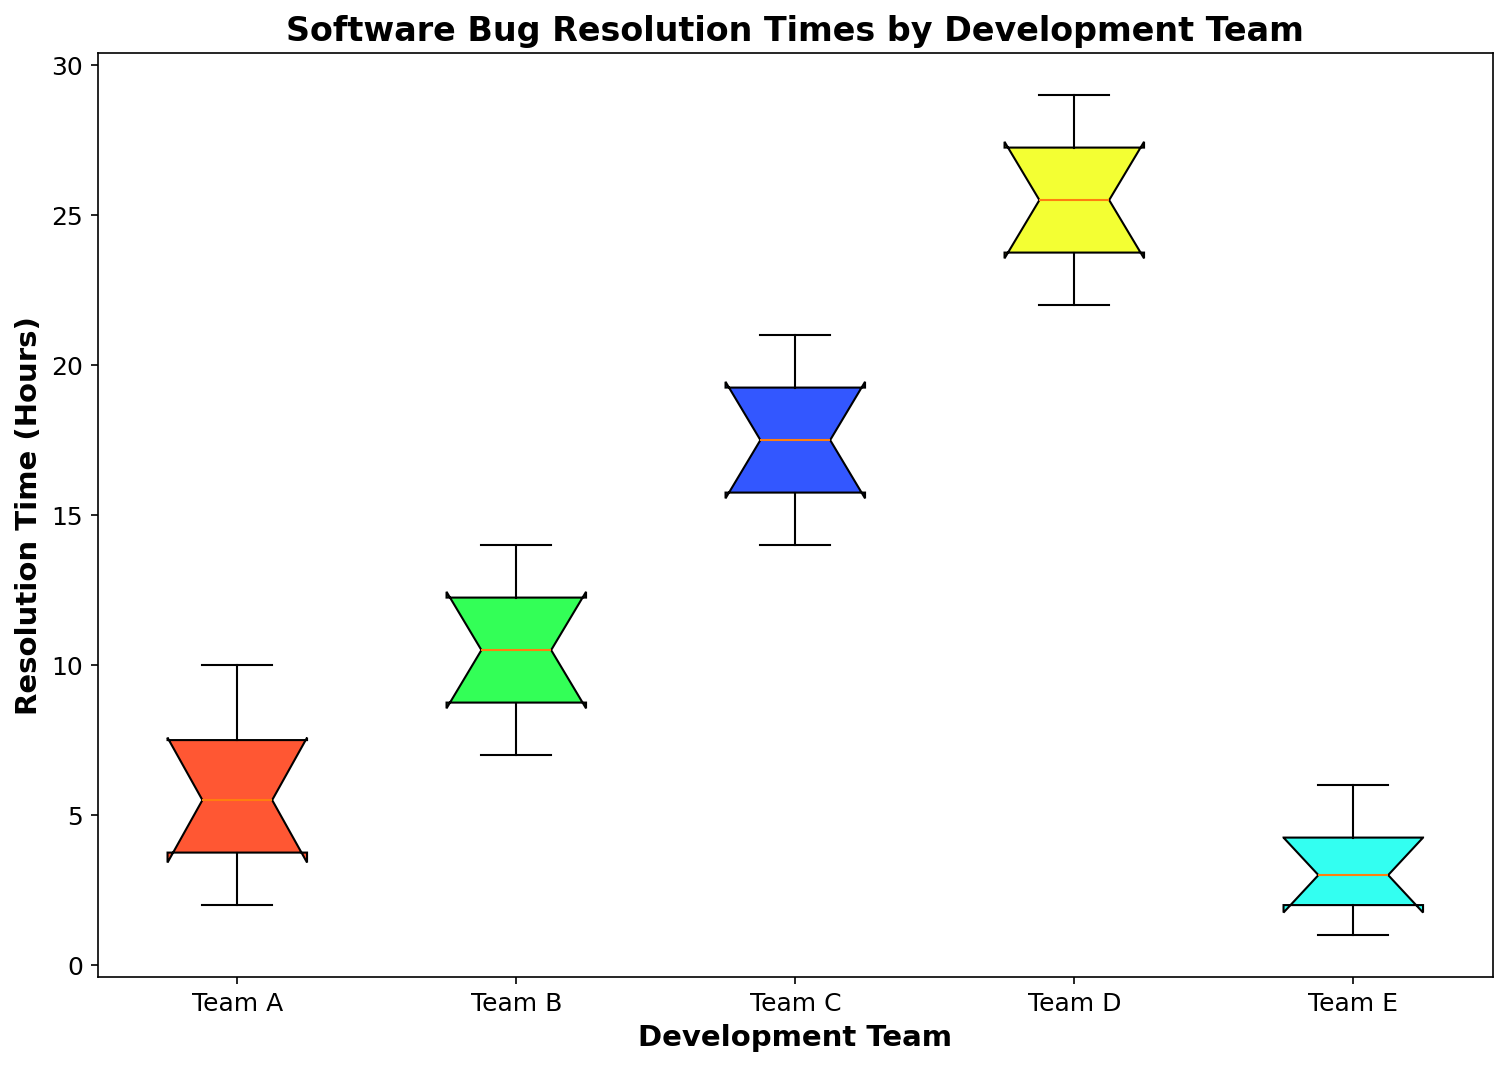Which development team has the smallest range of resolution times? The range of resolution times can be estimated by the distance between the minimum and maximum points of each box plot. For Team E, the minimum is 1 and the maximum is 6, giving a range of 5 hours, which is the smallest among all teams.
Answer: Team E What is the median resolution time for Team A? The median value is represented by the line inside the box. For Team A, the median resolution time is observed to be approximately 5 hours.
Answer: 5 hours Which development team has the highest upper quartile value? The upper quartile value is the top edge of the box. For Team D, the upper quartile is around 27 hours, which is higher than that of the other teams.
Answer: Team D Compare the medians of Team B and Team C. Which one is greater and by how much? The median value (the central line in the box) of Team B is around 10 hours, whereas for Team C it is observed to be around 17. Hence, Team C's median is greater by 7 hours.
Answer: Team C, by 7 hours How many teams have an interquartile range (IQR) less than 8 hours? The IQR is the difference between the upper quartile and lower quartile (the top and bottom edges of the box). Teams A, E, and C have IQRs less than 8 hours.
Answer: 3 teams Which team’s resolution times are the most widely spread? The spread can be observed by looking at the lengths of the "whiskers" of the box plot. Team D seems to have the widest spread, ranging approximately from 22 to 29 hours, making it the most spread out.
Answer: Team D Which development teams have outliers? Outliers are generally represented by individual points outside the whiskers. Upon inspection, no teams show outliers in this figure.
Answer: None Among the teams with overlapping interquartile ranges (Q1 to Q3), which team has the higher historical low resolution time: Team B or Team C? By looking at the bottom edge of the whisker (minimum value) of Team B and Team C, Team C has a higher historical low resolution time at around 14 hours compared to Team B at around 7 hours.
Answer: Team C What is the approximate IQR (Inter-Quartile Range) for Team A? The IQR is calculated by subtracting the lower quartile (Q1) from the upper quartile (Q3). For Team A, Q3 is around 7.5 and Q1 is around 3.5, so the IQR is 7.5 - 3.5 = 4 hours.
Answer: 4 hours 